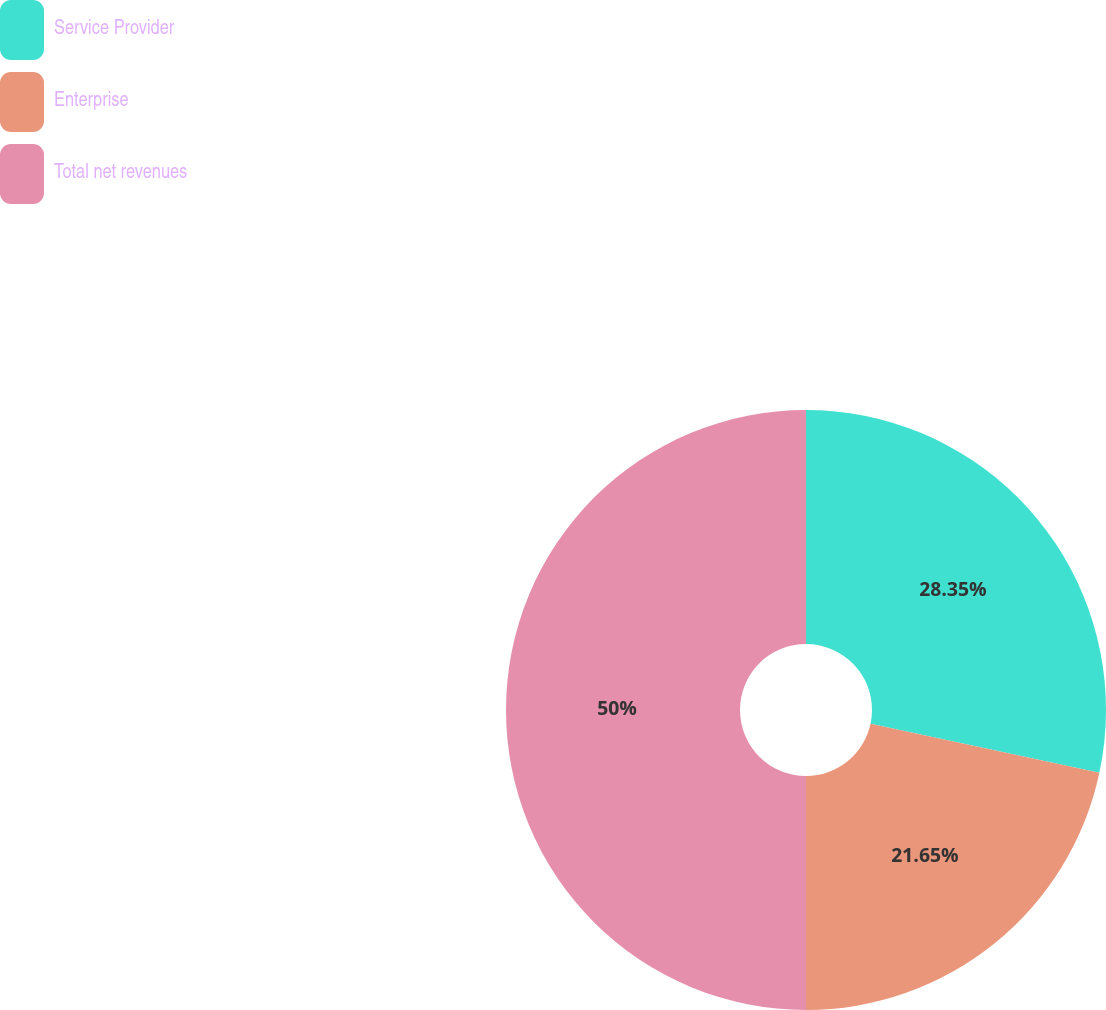<chart> <loc_0><loc_0><loc_500><loc_500><pie_chart><fcel>Service Provider<fcel>Enterprise<fcel>Total net revenues<nl><fcel>28.35%<fcel>21.65%<fcel>50.0%<nl></chart> 